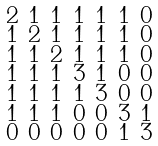Convert formula to latex. <formula><loc_0><loc_0><loc_500><loc_500>\begin{smallmatrix} 2 & 1 & 1 & 1 & 1 & 1 & 0 \\ 1 & 2 & 1 & 1 & 1 & 1 & 0 \\ 1 & 1 & 2 & 1 & 1 & 1 & 0 \\ 1 & 1 & 1 & 3 & 1 & 0 & 0 \\ 1 & 1 & 1 & 1 & 3 & 0 & 0 \\ 1 & 1 & 1 & 0 & 0 & 3 & 1 \\ 0 & 0 & 0 & 0 & 0 & 1 & 3 \end{smallmatrix}</formula> 